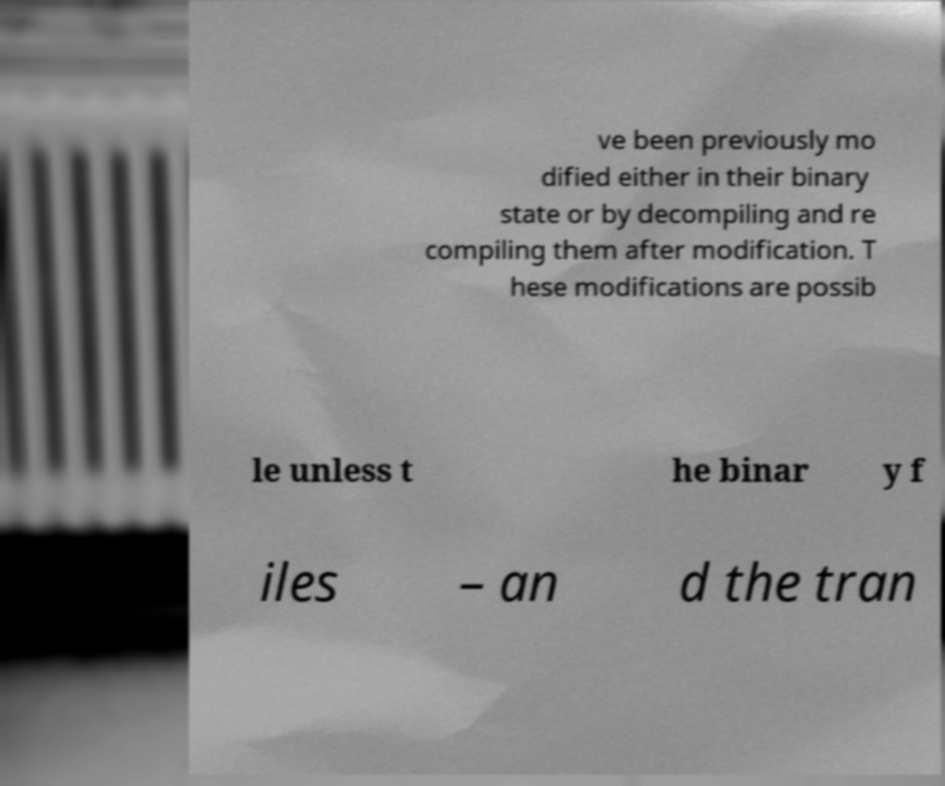Could you extract and type out the text from this image? ve been previously mo dified either in their binary state or by decompiling and re compiling them after modification. T hese modifications are possib le unless t he binar y f iles – an d the tran 